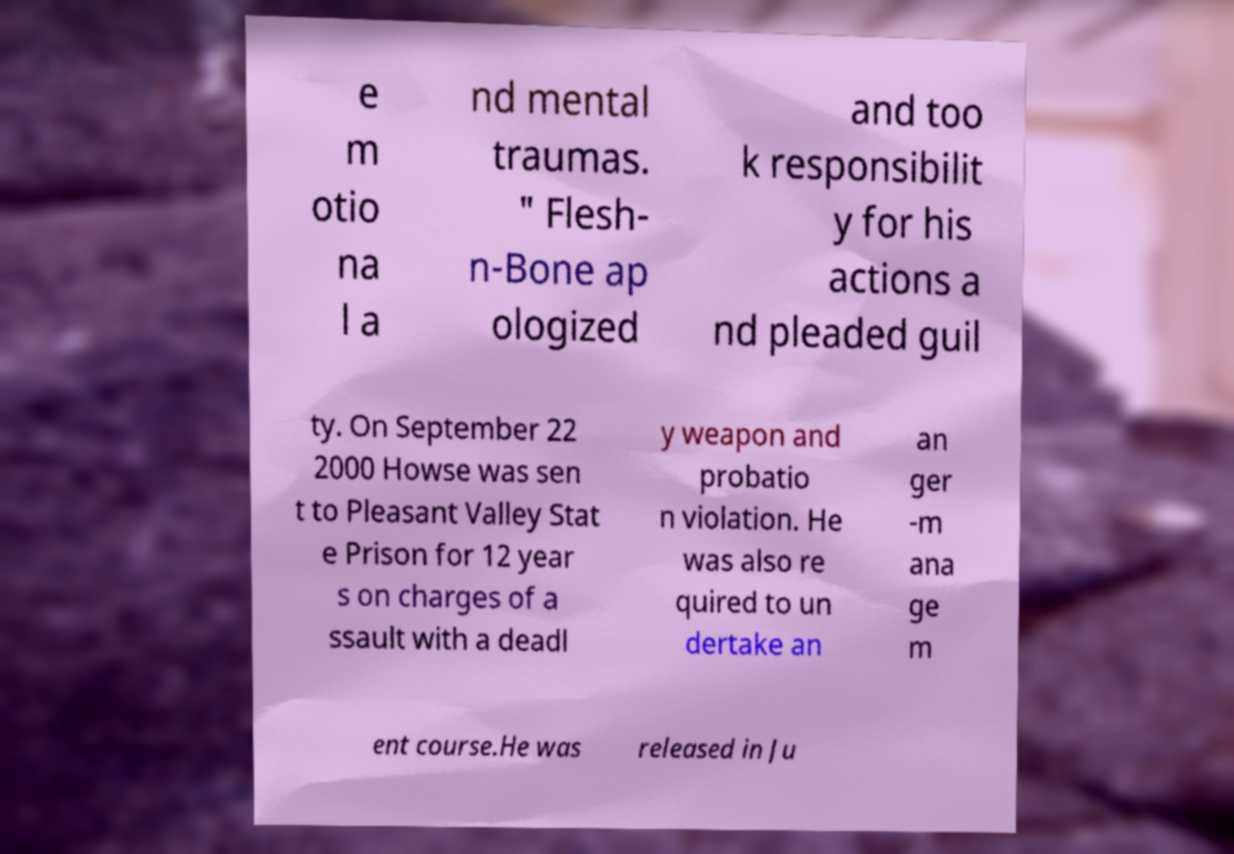Please identify and transcribe the text found in this image. e m otio na l a nd mental traumas. " Flesh- n-Bone ap ologized and too k responsibilit y for his actions a nd pleaded guil ty. On September 22 2000 Howse was sen t to Pleasant Valley Stat e Prison for 12 year s on charges of a ssault with a deadl y weapon and probatio n violation. He was also re quired to un dertake an an ger -m ana ge m ent course.He was released in Ju 